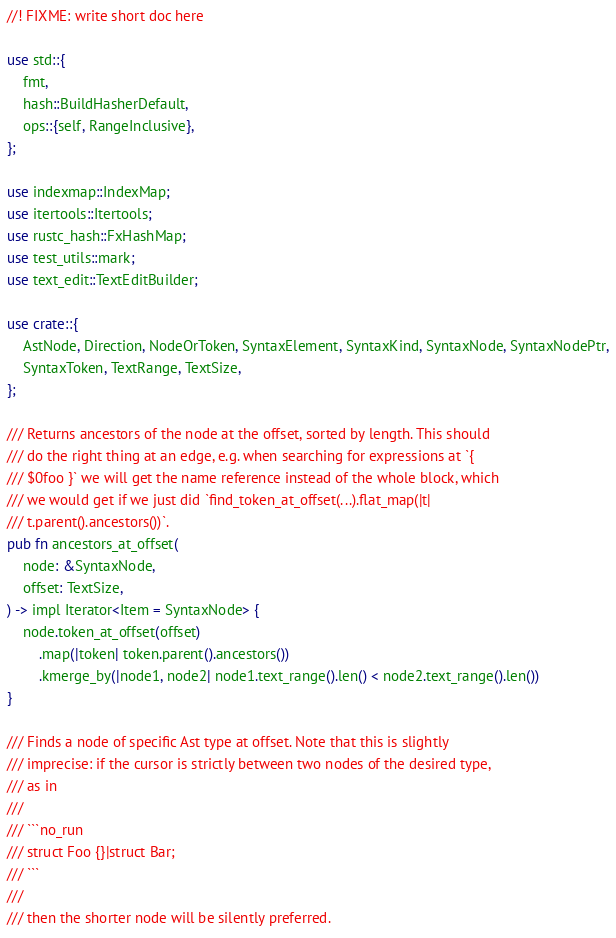<code> <loc_0><loc_0><loc_500><loc_500><_Rust_>//! FIXME: write short doc here

use std::{
    fmt,
    hash::BuildHasherDefault,
    ops::{self, RangeInclusive},
};

use indexmap::IndexMap;
use itertools::Itertools;
use rustc_hash::FxHashMap;
use test_utils::mark;
use text_edit::TextEditBuilder;

use crate::{
    AstNode, Direction, NodeOrToken, SyntaxElement, SyntaxKind, SyntaxNode, SyntaxNodePtr,
    SyntaxToken, TextRange, TextSize,
};

/// Returns ancestors of the node at the offset, sorted by length. This should
/// do the right thing at an edge, e.g. when searching for expressions at `{
/// $0foo }` we will get the name reference instead of the whole block, which
/// we would get if we just did `find_token_at_offset(...).flat_map(|t|
/// t.parent().ancestors())`.
pub fn ancestors_at_offset(
    node: &SyntaxNode,
    offset: TextSize,
) -> impl Iterator<Item = SyntaxNode> {
    node.token_at_offset(offset)
        .map(|token| token.parent().ancestors())
        .kmerge_by(|node1, node2| node1.text_range().len() < node2.text_range().len())
}

/// Finds a node of specific Ast type at offset. Note that this is slightly
/// imprecise: if the cursor is strictly between two nodes of the desired type,
/// as in
///
/// ```no_run
/// struct Foo {}|struct Bar;
/// ```
///
/// then the shorter node will be silently preferred.</code> 